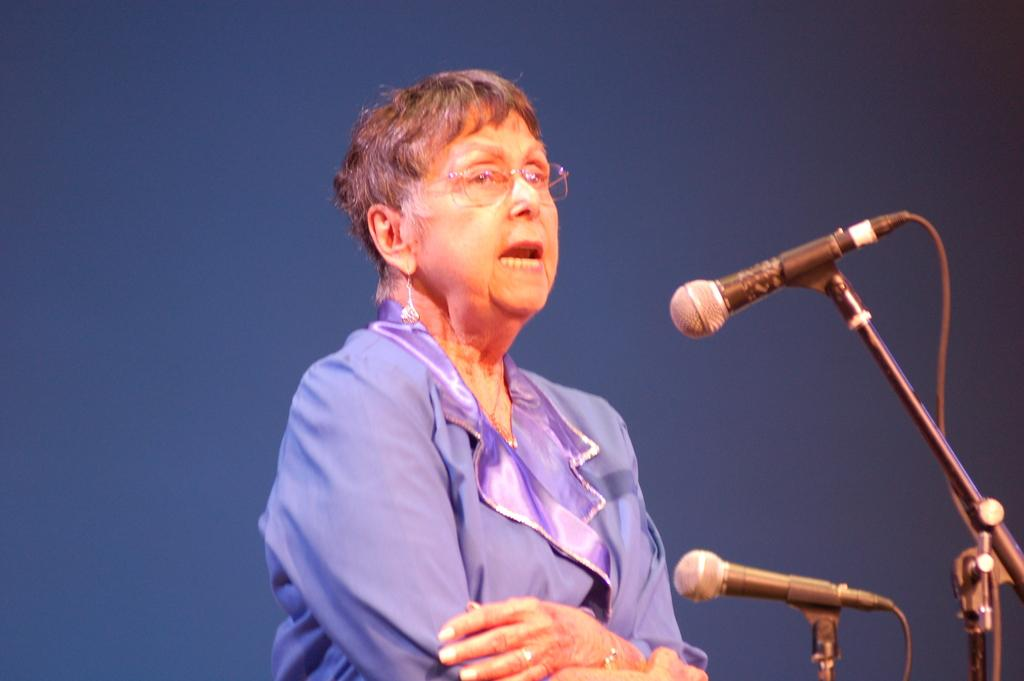Who is the main subject in the image? There is a woman in the image. What is the woman wearing? The woman is wearing a blue dress and glasses (specs). What objects are in front of the woman? There are two microphones in front of the woman. What color can be seen in the background of the image? There is blue color visible in the background of the image. What time of day is it in the image, and is the woman in bed? The time of day is not mentioned in the image, and there is no indication that the woman is in bed. Can you describe the coil-like structure visible in the image? There is no coil-like structure visible in the image. 